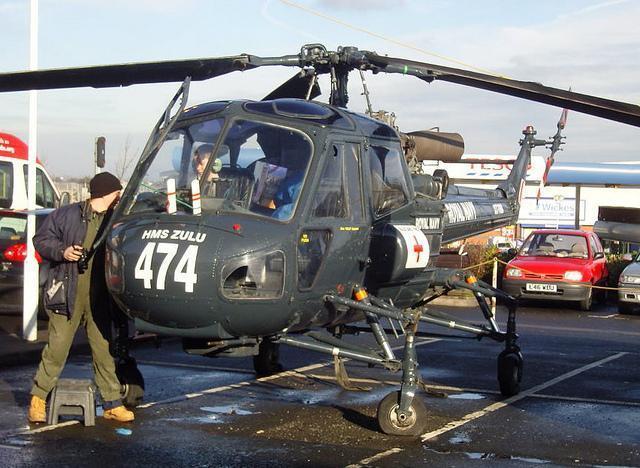How many of the cats paws are on the desk?
Give a very brief answer. 0. 